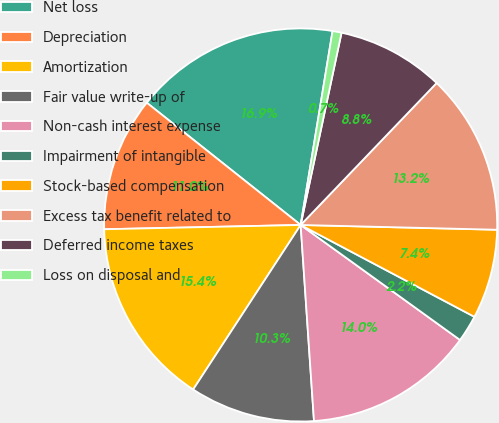Convert chart to OTSL. <chart><loc_0><loc_0><loc_500><loc_500><pie_chart><fcel>Net loss<fcel>Depreciation<fcel>Amortization<fcel>Fair value write-up of<fcel>Non-cash interest expense<fcel>Impairment of intangible<fcel>Stock-based compensation<fcel>Excess tax benefit related to<fcel>Deferred income taxes<fcel>Loss on disposal and<nl><fcel>16.91%<fcel>11.03%<fcel>15.44%<fcel>10.29%<fcel>13.97%<fcel>2.21%<fcel>7.35%<fcel>13.23%<fcel>8.82%<fcel>0.74%<nl></chart> 